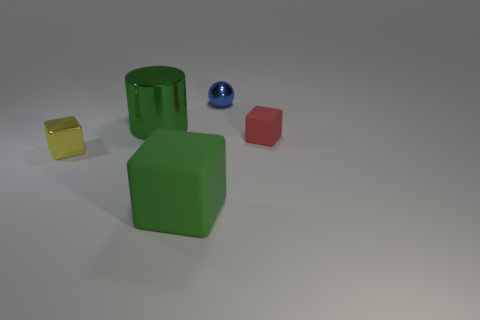Add 4 tiny matte cylinders. How many objects exist? 9 Subtract all cylinders. How many objects are left? 4 Add 3 big green cylinders. How many big green cylinders exist? 4 Subtract 0 purple spheres. How many objects are left? 5 Subtract all big cyan cylinders. Subtract all tiny balls. How many objects are left? 4 Add 1 small blue objects. How many small blue objects are left? 2 